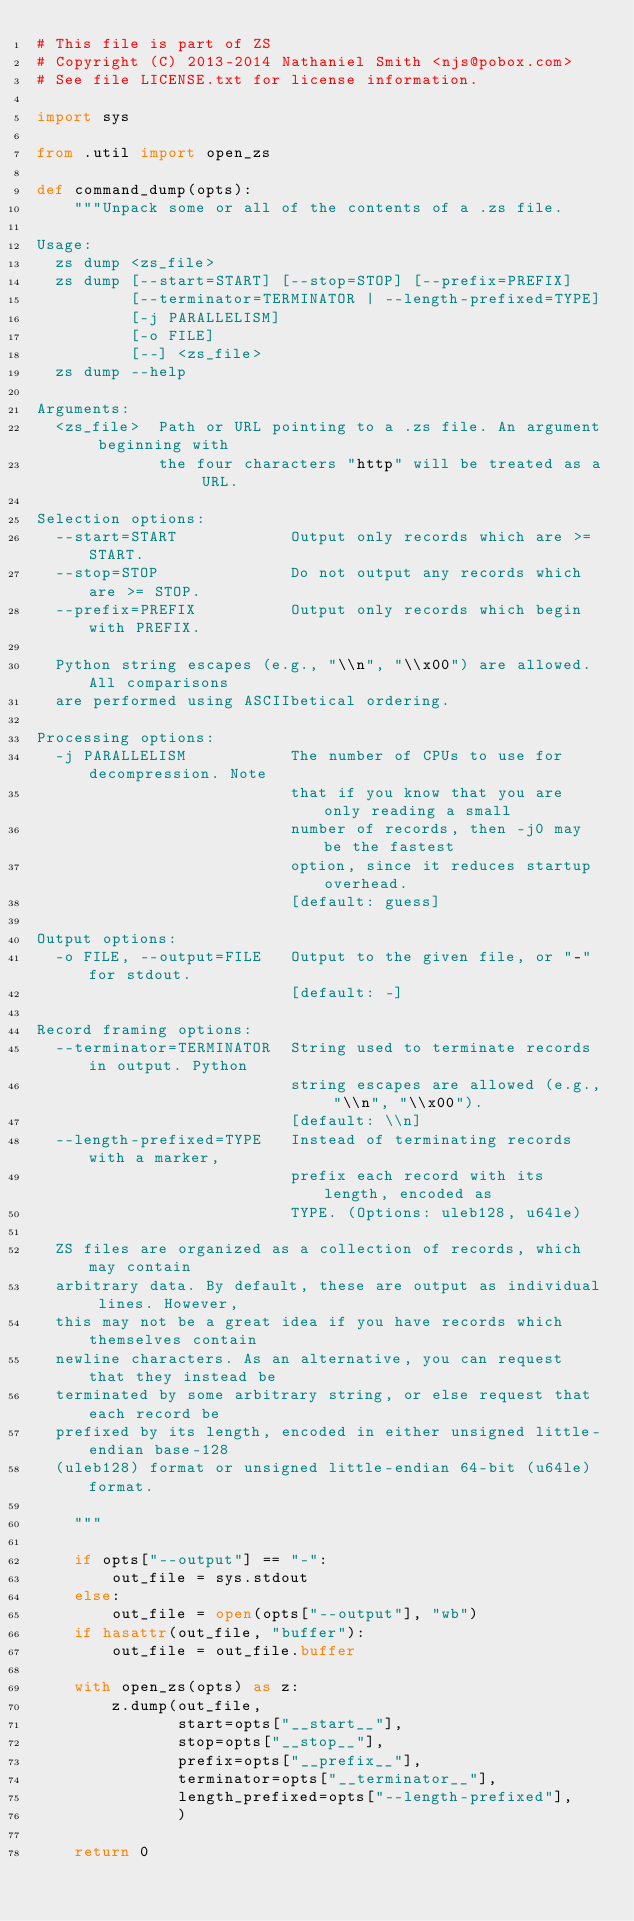<code> <loc_0><loc_0><loc_500><loc_500><_Python_># This file is part of ZS
# Copyright (C) 2013-2014 Nathaniel Smith <njs@pobox.com>
# See file LICENSE.txt for license information.

import sys

from .util import open_zs

def command_dump(opts):
    """Unpack some or all of the contents of a .zs file.

Usage:
  zs dump <zs_file>
  zs dump [--start=START] [--stop=STOP] [--prefix=PREFIX]
          [--terminator=TERMINATOR | --length-prefixed=TYPE]
          [-j PARALLELISM]
          [-o FILE]
          [--] <zs_file>
  zs dump --help

Arguments:
  <zs_file>  Path or URL pointing to a .zs file. An argument beginning with
             the four characters "http" will be treated as a URL.

Selection options:
  --start=START            Output only records which are >= START.
  --stop=STOP              Do not output any records which are >= STOP.
  --prefix=PREFIX          Output only records which begin with PREFIX.

  Python string escapes (e.g., "\\n", "\\x00") are allowed. All comparisons
  are performed using ASCIIbetical ordering.

Processing options:
  -j PARALLELISM           The number of CPUs to use for decompression. Note
                           that if you know that you are only reading a small
                           number of records, then -j0 may be the fastest
                           option, since it reduces startup overhead.
                           [default: guess]

Output options:
  -o FILE, --output=FILE   Output to the given file, or "-" for stdout.
                           [default: -]

Record framing options:
  --terminator=TERMINATOR  String used to terminate records in output. Python
                           string escapes are allowed (e.g., "\\n", "\\x00").
                           [default: \\n]
  --length-prefixed=TYPE   Instead of terminating records with a marker,
                           prefix each record with its length, encoded as
                           TYPE. (Options: uleb128, u64le)

  ZS files are organized as a collection of records, which may contain
  arbitrary data. By default, these are output as individual lines. However,
  this may not be a great idea if you have records which themselves contain
  newline characters. As an alternative, you can request that they instead be
  terminated by some arbitrary string, or else request that each record be
  prefixed by its length, encoded in either unsigned little-endian base-128
  (uleb128) format or unsigned little-endian 64-bit (u64le) format.

    """

    if opts["--output"] == "-":
        out_file = sys.stdout
    else:
        out_file = open(opts["--output"], "wb")
    if hasattr(out_file, "buffer"):
        out_file = out_file.buffer

    with open_zs(opts) as z:
        z.dump(out_file,
               start=opts["__start__"],
               stop=opts["__stop__"],
               prefix=opts["__prefix__"],
               terminator=opts["__terminator__"],
               length_prefixed=opts["--length-prefixed"],
               )

    return 0
</code> 